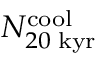<formula> <loc_0><loc_0><loc_500><loc_500>N _ { 2 0 \, k y r } ^ { c o o l }</formula> 